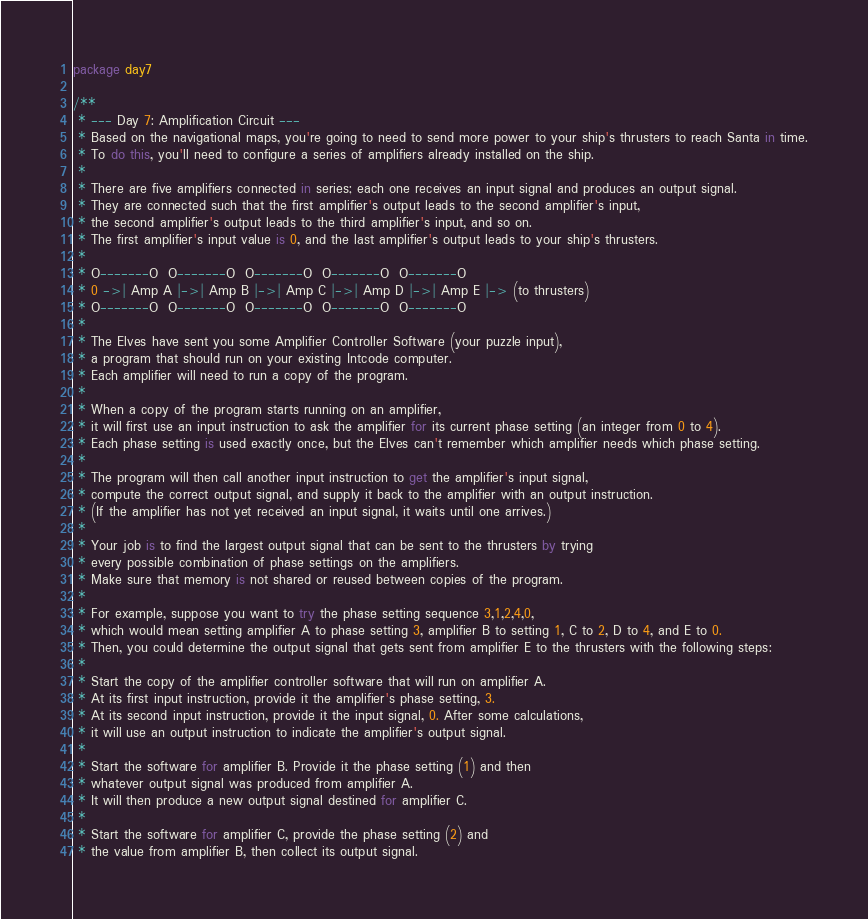<code> <loc_0><loc_0><loc_500><loc_500><_Kotlin_>package day7

/**
 * --- Day 7: Amplification Circuit ---
 * Based on the navigational maps, you're going to need to send more power to your ship's thrusters to reach Santa in time.
 * To do this, you'll need to configure a series of amplifiers already installed on the ship.
 *
 * There are five amplifiers connected in series; each one receives an input signal and produces an output signal.
 * They are connected such that the first amplifier's output leads to the second amplifier's input,
 * the second amplifier's output leads to the third amplifier's input, and so on.
 * The first amplifier's input value is 0, and the last amplifier's output leads to your ship's thrusters.
 *
 * O-------O  O-------O  O-------O  O-------O  O-------O
 * 0 ->| Amp A |->| Amp B |->| Amp C |->| Amp D |->| Amp E |-> (to thrusters)
 * O-------O  O-------O  O-------O  O-------O  O-------O
 *
 * The Elves have sent you some Amplifier Controller Software (your puzzle input),
 * a program that should run on your existing Intcode computer.
 * Each amplifier will need to run a copy of the program.
 *
 * When a copy of the program starts running on an amplifier,
 * it will first use an input instruction to ask the amplifier for its current phase setting (an integer from 0 to 4).
 * Each phase setting is used exactly once, but the Elves can't remember which amplifier needs which phase setting.
 *
 * The program will then call another input instruction to get the amplifier's input signal,
 * compute the correct output signal, and supply it back to the amplifier with an output instruction.
 * (If the amplifier has not yet received an input signal, it waits until one arrives.)
 *
 * Your job is to find the largest output signal that can be sent to the thrusters by trying
 * every possible combination of phase settings on the amplifiers.
 * Make sure that memory is not shared or reused between copies of the program.
 *
 * For example, suppose you want to try the phase setting sequence 3,1,2,4,0,
 * which would mean setting amplifier A to phase setting 3, amplifier B to setting 1, C to 2, D to 4, and E to 0.
 * Then, you could determine the output signal that gets sent from amplifier E to the thrusters with the following steps:
 *
 * Start the copy of the amplifier controller software that will run on amplifier A.
 * At its first input instruction, provide it the amplifier's phase setting, 3.
 * At its second input instruction, provide it the input signal, 0. After some calculations,
 * it will use an output instruction to indicate the amplifier's output signal.
 *
 * Start the software for amplifier B. Provide it the phase setting (1) and then
 * whatever output signal was produced from amplifier A.
 * It will then produce a new output signal destined for amplifier C.
 *
 * Start the software for amplifier C, provide the phase setting (2) and
 * the value from amplifier B, then collect its output signal.</code> 